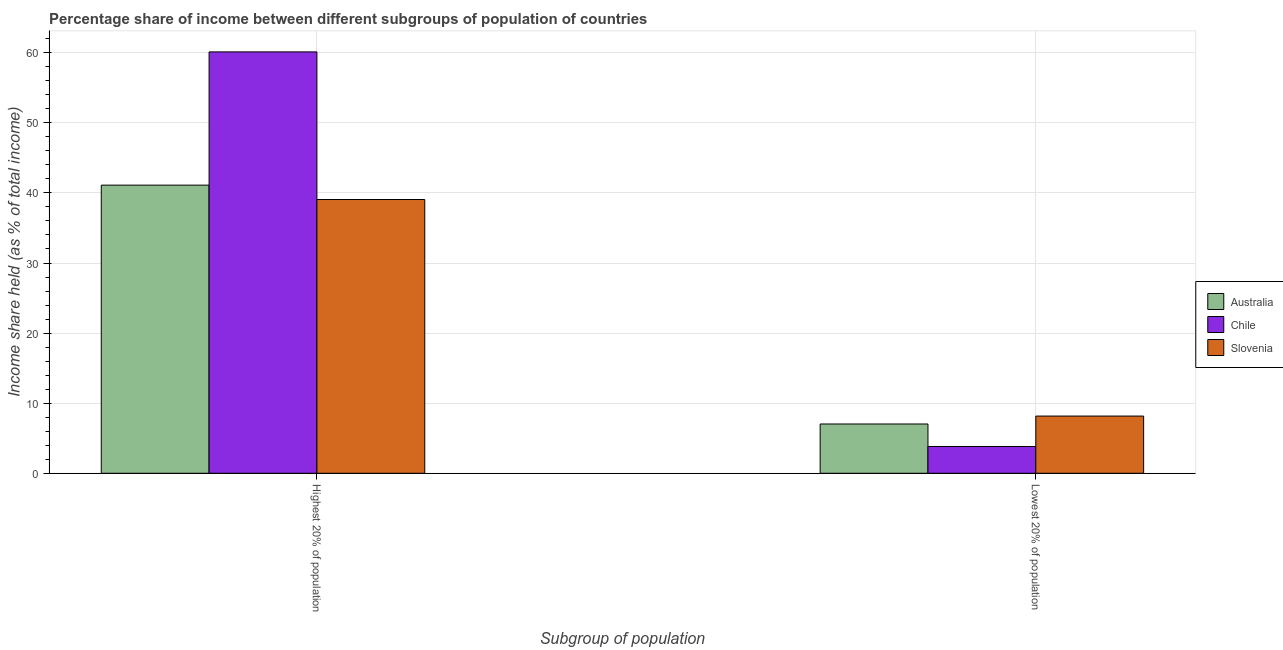How many groups of bars are there?
Your answer should be compact. 2. Are the number of bars per tick equal to the number of legend labels?
Your answer should be very brief. Yes. How many bars are there on the 1st tick from the right?
Make the answer very short. 3. What is the label of the 1st group of bars from the left?
Offer a terse response. Highest 20% of population. What is the income share held by lowest 20% of the population in Slovenia?
Give a very brief answer. 8.16. Across all countries, what is the maximum income share held by lowest 20% of the population?
Provide a succinct answer. 8.16. Across all countries, what is the minimum income share held by lowest 20% of the population?
Your response must be concise. 3.82. In which country was the income share held by lowest 20% of the population maximum?
Offer a terse response. Slovenia. In which country was the income share held by highest 20% of the population minimum?
Provide a short and direct response. Slovenia. What is the total income share held by lowest 20% of the population in the graph?
Your answer should be very brief. 19.01. What is the difference between the income share held by highest 20% of the population in Slovenia and that in Australia?
Provide a short and direct response. -2.05. What is the difference between the income share held by highest 20% of the population in Australia and the income share held by lowest 20% of the population in Slovenia?
Provide a succinct answer. 32.95. What is the average income share held by highest 20% of the population per country?
Your response must be concise. 46.76. What is the difference between the income share held by lowest 20% of the population and income share held by highest 20% of the population in Slovenia?
Your response must be concise. -30.9. What is the ratio of the income share held by highest 20% of the population in Chile to that in Australia?
Give a very brief answer. 1.46. In how many countries, is the income share held by highest 20% of the population greater than the average income share held by highest 20% of the population taken over all countries?
Keep it short and to the point. 1. What does the 1st bar from the right in Lowest 20% of population represents?
Your answer should be very brief. Slovenia. How many bars are there?
Make the answer very short. 6. Are the values on the major ticks of Y-axis written in scientific E-notation?
Offer a very short reply. No. Does the graph contain any zero values?
Your response must be concise. No. Where does the legend appear in the graph?
Offer a terse response. Center right. How many legend labels are there?
Offer a very short reply. 3. What is the title of the graph?
Provide a succinct answer. Percentage share of income between different subgroups of population of countries. What is the label or title of the X-axis?
Your answer should be very brief. Subgroup of population. What is the label or title of the Y-axis?
Your response must be concise. Income share held (as % of total income). What is the Income share held (as % of total income) in Australia in Highest 20% of population?
Offer a terse response. 41.11. What is the Income share held (as % of total income) of Chile in Highest 20% of population?
Ensure brevity in your answer.  60.12. What is the Income share held (as % of total income) of Slovenia in Highest 20% of population?
Provide a succinct answer. 39.06. What is the Income share held (as % of total income) of Australia in Lowest 20% of population?
Offer a very short reply. 7.03. What is the Income share held (as % of total income) of Chile in Lowest 20% of population?
Your response must be concise. 3.82. What is the Income share held (as % of total income) of Slovenia in Lowest 20% of population?
Ensure brevity in your answer.  8.16. Across all Subgroup of population, what is the maximum Income share held (as % of total income) of Australia?
Keep it short and to the point. 41.11. Across all Subgroup of population, what is the maximum Income share held (as % of total income) of Chile?
Give a very brief answer. 60.12. Across all Subgroup of population, what is the maximum Income share held (as % of total income) of Slovenia?
Your answer should be very brief. 39.06. Across all Subgroup of population, what is the minimum Income share held (as % of total income) in Australia?
Offer a terse response. 7.03. Across all Subgroup of population, what is the minimum Income share held (as % of total income) of Chile?
Make the answer very short. 3.82. Across all Subgroup of population, what is the minimum Income share held (as % of total income) of Slovenia?
Ensure brevity in your answer.  8.16. What is the total Income share held (as % of total income) of Australia in the graph?
Your answer should be very brief. 48.14. What is the total Income share held (as % of total income) of Chile in the graph?
Keep it short and to the point. 63.94. What is the total Income share held (as % of total income) of Slovenia in the graph?
Offer a very short reply. 47.22. What is the difference between the Income share held (as % of total income) of Australia in Highest 20% of population and that in Lowest 20% of population?
Your answer should be compact. 34.08. What is the difference between the Income share held (as % of total income) in Chile in Highest 20% of population and that in Lowest 20% of population?
Offer a very short reply. 56.3. What is the difference between the Income share held (as % of total income) of Slovenia in Highest 20% of population and that in Lowest 20% of population?
Offer a very short reply. 30.9. What is the difference between the Income share held (as % of total income) in Australia in Highest 20% of population and the Income share held (as % of total income) in Chile in Lowest 20% of population?
Ensure brevity in your answer.  37.29. What is the difference between the Income share held (as % of total income) of Australia in Highest 20% of population and the Income share held (as % of total income) of Slovenia in Lowest 20% of population?
Offer a terse response. 32.95. What is the difference between the Income share held (as % of total income) in Chile in Highest 20% of population and the Income share held (as % of total income) in Slovenia in Lowest 20% of population?
Provide a succinct answer. 51.96. What is the average Income share held (as % of total income) of Australia per Subgroup of population?
Give a very brief answer. 24.07. What is the average Income share held (as % of total income) in Chile per Subgroup of population?
Keep it short and to the point. 31.97. What is the average Income share held (as % of total income) of Slovenia per Subgroup of population?
Keep it short and to the point. 23.61. What is the difference between the Income share held (as % of total income) of Australia and Income share held (as % of total income) of Chile in Highest 20% of population?
Offer a terse response. -19.01. What is the difference between the Income share held (as % of total income) in Australia and Income share held (as % of total income) in Slovenia in Highest 20% of population?
Give a very brief answer. 2.05. What is the difference between the Income share held (as % of total income) of Chile and Income share held (as % of total income) of Slovenia in Highest 20% of population?
Your response must be concise. 21.06. What is the difference between the Income share held (as % of total income) in Australia and Income share held (as % of total income) in Chile in Lowest 20% of population?
Provide a succinct answer. 3.21. What is the difference between the Income share held (as % of total income) of Australia and Income share held (as % of total income) of Slovenia in Lowest 20% of population?
Your answer should be compact. -1.13. What is the difference between the Income share held (as % of total income) of Chile and Income share held (as % of total income) of Slovenia in Lowest 20% of population?
Keep it short and to the point. -4.34. What is the ratio of the Income share held (as % of total income) in Australia in Highest 20% of population to that in Lowest 20% of population?
Your response must be concise. 5.85. What is the ratio of the Income share held (as % of total income) in Chile in Highest 20% of population to that in Lowest 20% of population?
Provide a succinct answer. 15.74. What is the ratio of the Income share held (as % of total income) in Slovenia in Highest 20% of population to that in Lowest 20% of population?
Make the answer very short. 4.79. What is the difference between the highest and the second highest Income share held (as % of total income) in Australia?
Your response must be concise. 34.08. What is the difference between the highest and the second highest Income share held (as % of total income) of Chile?
Your response must be concise. 56.3. What is the difference between the highest and the second highest Income share held (as % of total income) of Slovenia?
Your answer should be very brief. 30.9. What is the difference between the highest and the lowest Income share held (as % of total income) in Australia?
Your answer should be very brief. 34.08. What is the difference between the highest and the lowest Income share held (as % of total income) of Chile?
Provide a succinct answer. 56.3. What is the difference between the highest and the lowest Income share held (as % of total income) of Slovenia?
Provide a short and direct response. 30.9. 